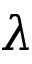<formula> <loc_0><loc_0><loc_500><loc_500>\lambda</formula> 